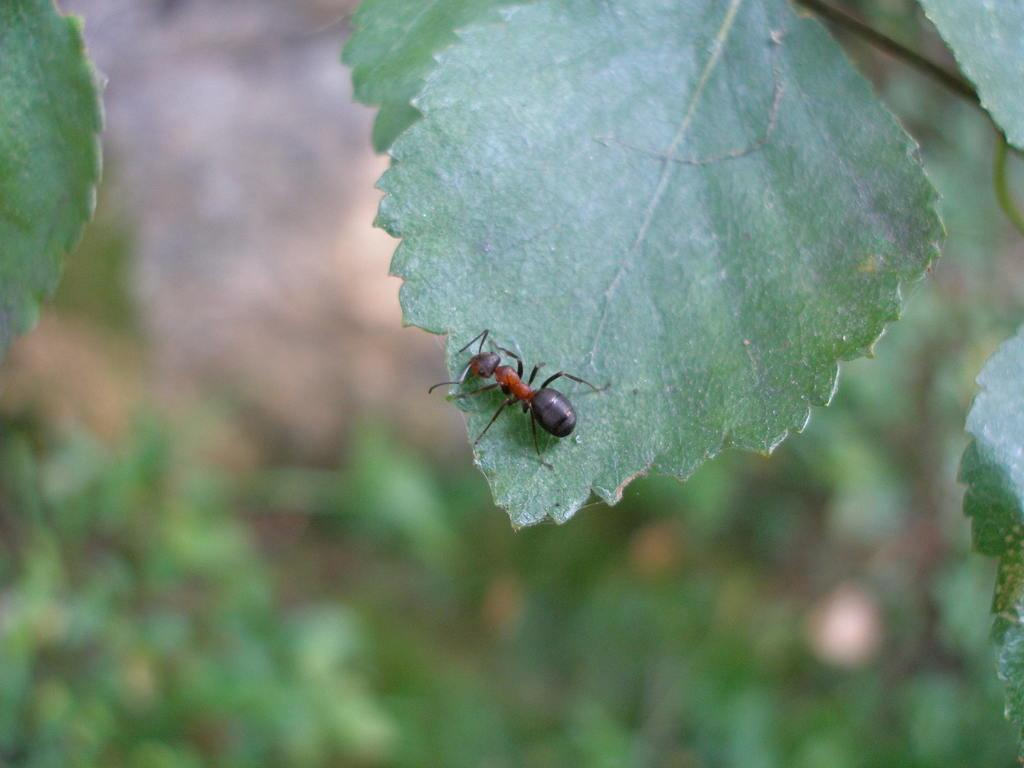What is the main subject in the foreground of the image? There is an ant on a leaf in the foreground of the image. What else can be seen in the image besides the ant? There are leaves visible in the image. Can you describe the background of the image? The background of the image is blurred. Is the dog sleeping on the cable in the image? There is no dog or cable present in the image. 